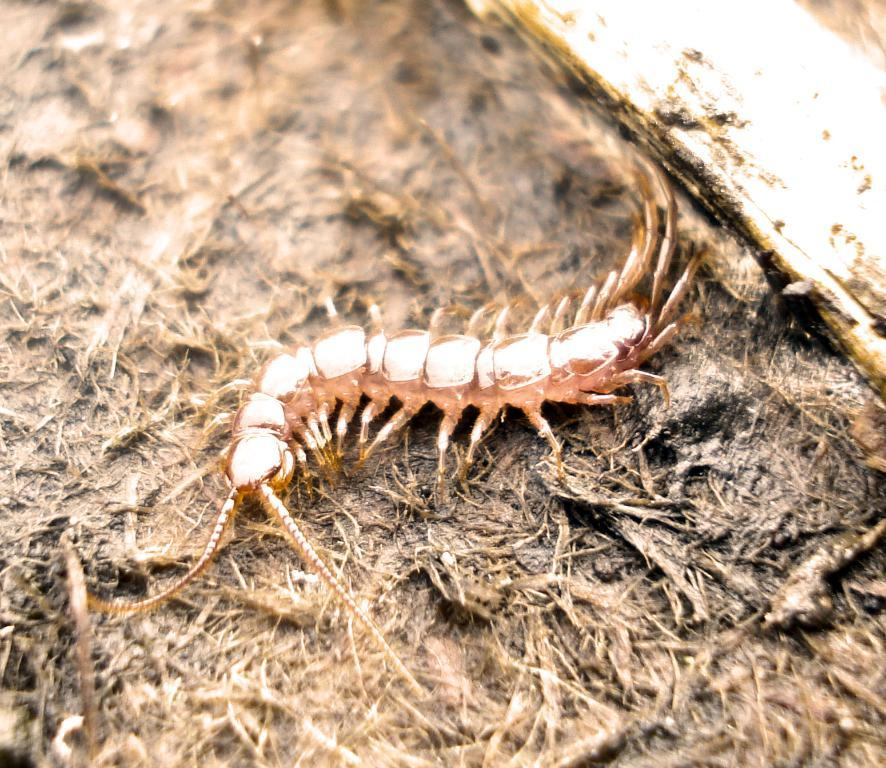What type of insect is in the image? There is a gold-colored insect in the image. Where is the insect located? The insect is on the ground. What can be seen in the top right corner of the image? There is an object in the top right corner of the image. What rule does the insect follow when interacting with the object in the image? There is no rule or interaction between the insect and the object in the image, as they are separate entities. 